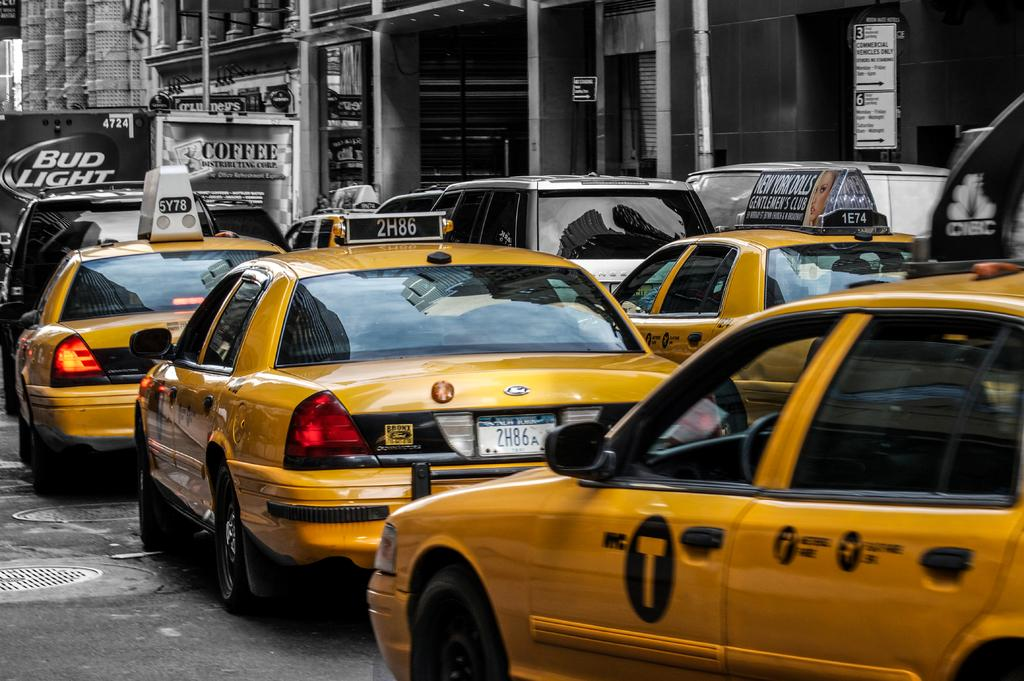Provide a one-sentence caption for the provided image. A Bud Light truck is blocking the road. 